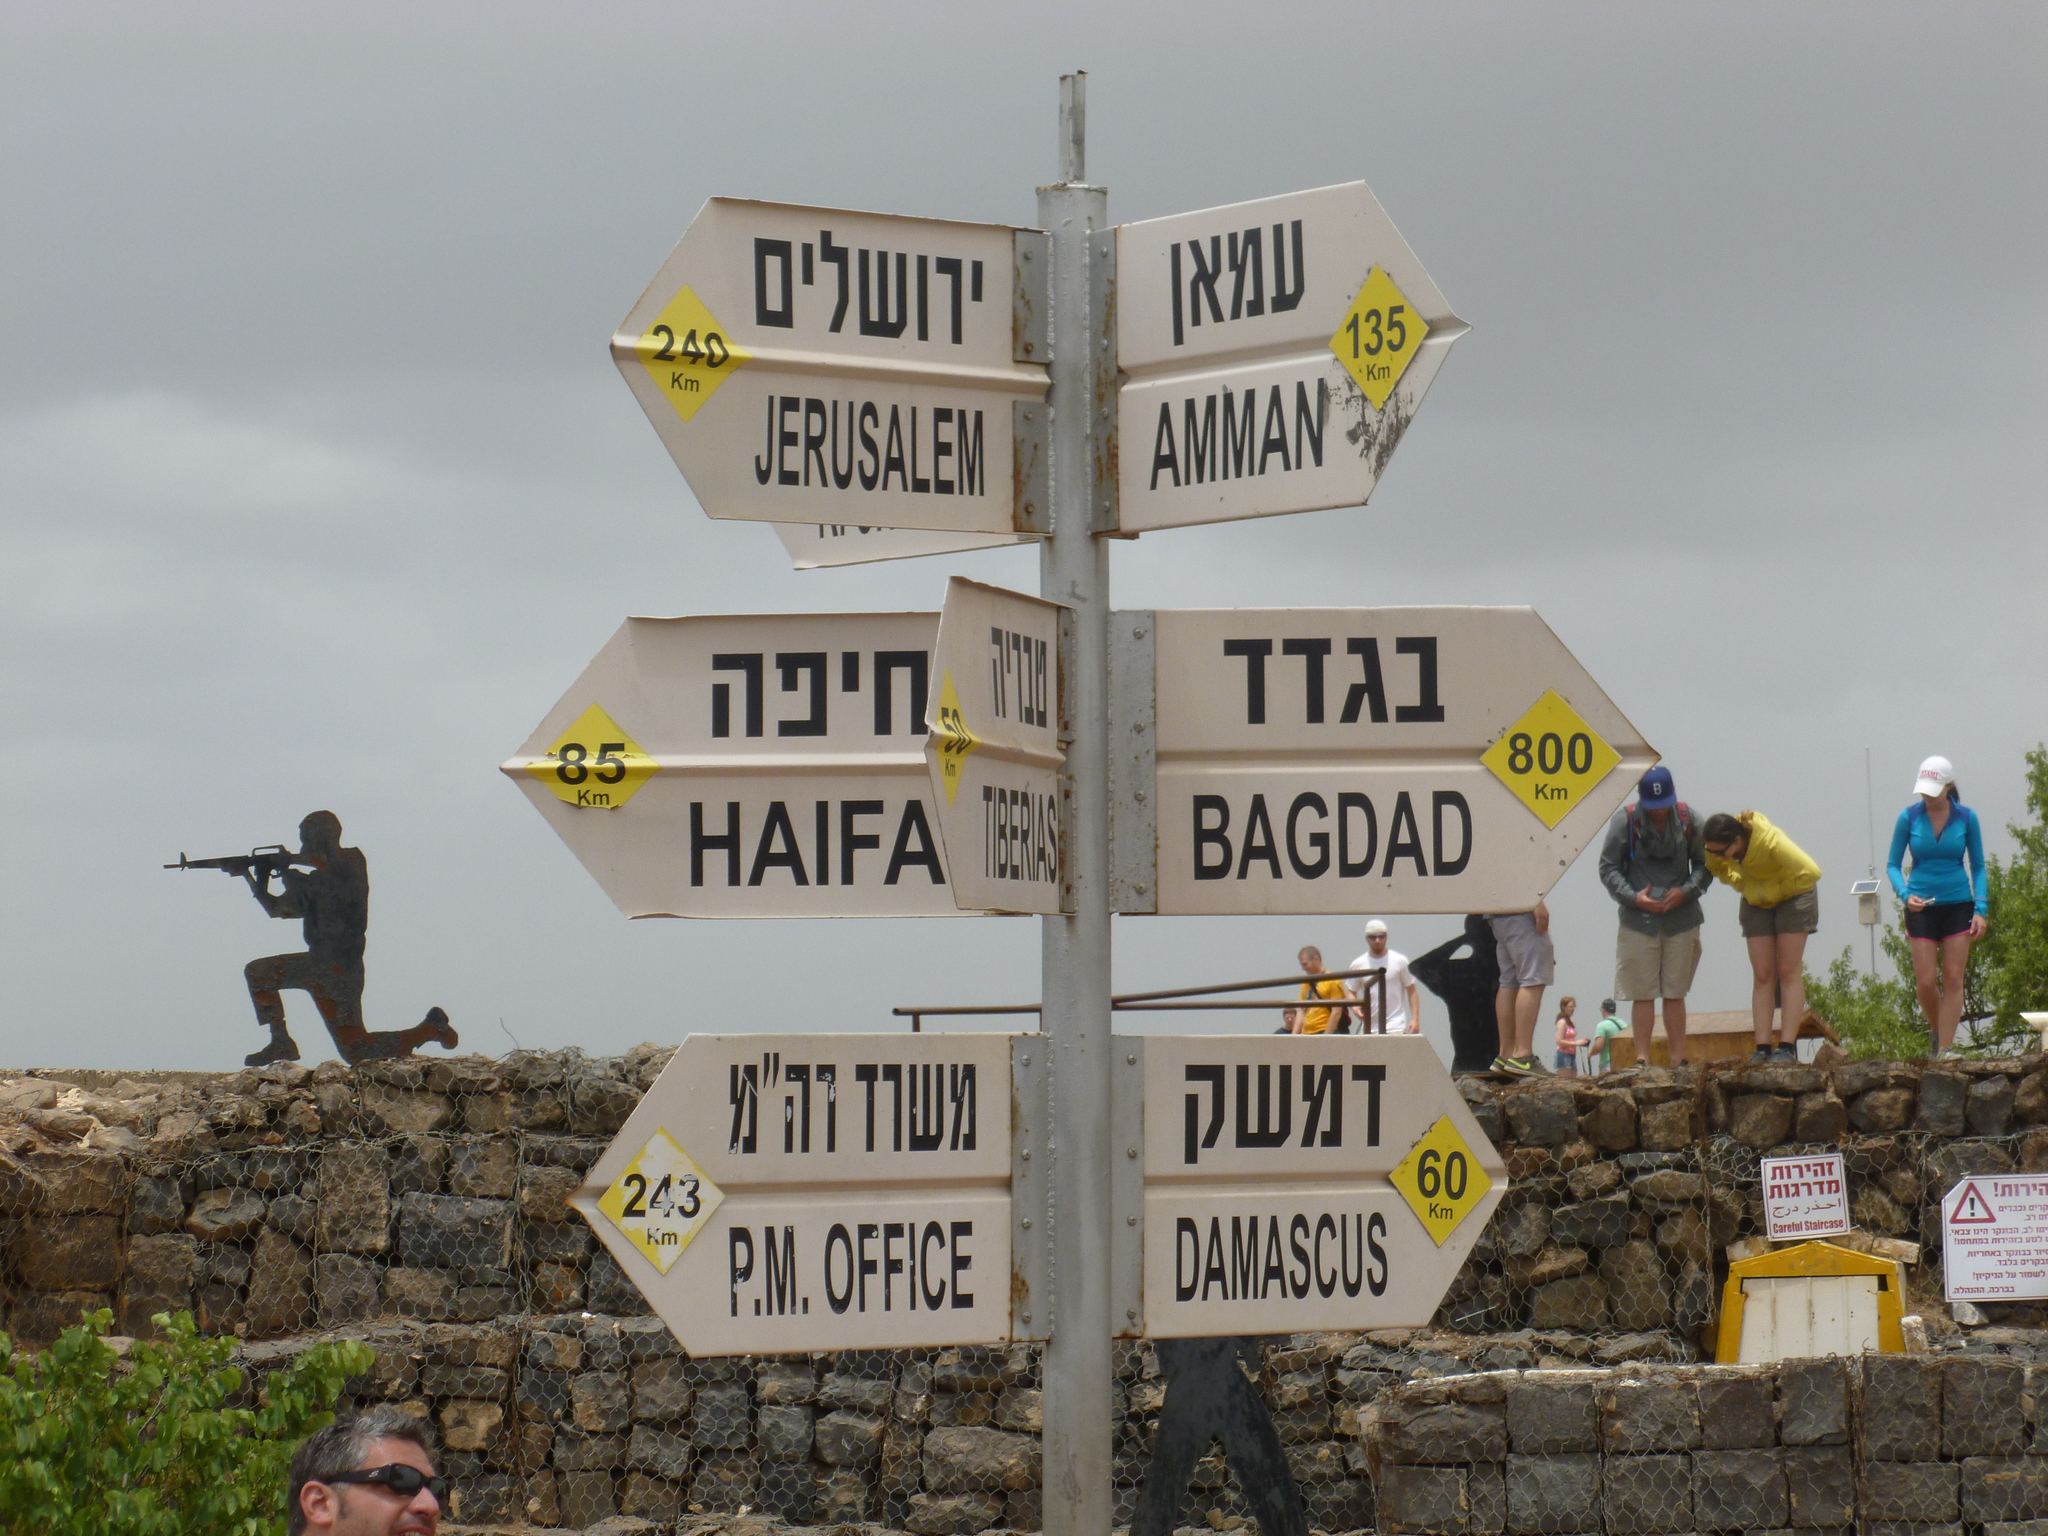<image>
Present a compact description of the photo's key features. A bank of directional signs, one of which shows Bagdad being to the right. 